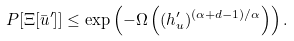<formula> <loc_0><loc_0><loc_500><loc_500>P [ \Xi [ \bar { u } ^ { \prime } ] ] \leq \exp \left ( - \Omega \left ( ( h ^ { \prime } _ { u } ) ^ { ( \alpha + d - 1 ) / \alpha } \right ) \right ) .</formula> 